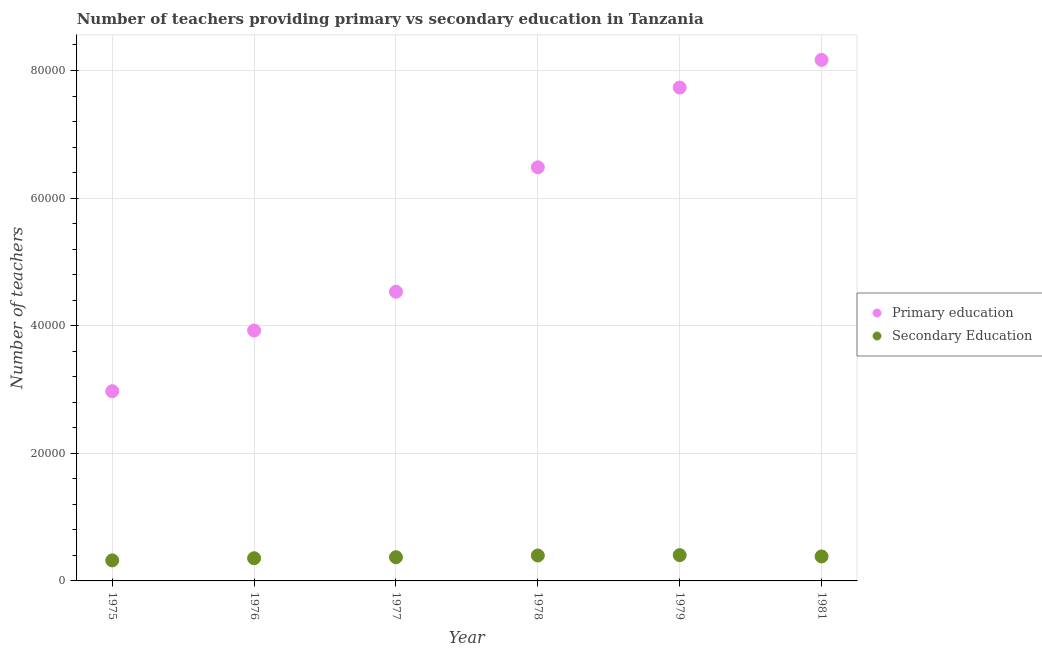How many different coloured dotlines are there?
Provide a succinct answer. 2. What is the number of secondary teachers in 1977?
Give a very brief answer. 3714. Across all years, what is the maximum number of primary teachers?
Offer a very short reply. 8.17e+04. Across all years, what is the minimum number of primary teachers?
Provide a short and direct response. 2.97e+04. In which year was the number of primary teachers minimum?
Ensure brevity in your answer.  1975. What is the total number of secondary teachers in the graph?
Provide a succinct answer. 2.23e+04. What is the difference between the number of primary teachers in 1975 and that in 1977?
Keep it short and to the point. -1.56e+04. What is the difference between the number of secondary teachers in 1975 and the number of primary teachers in 1976?
Provide a short and direct response. -3.60e+04. What is the average number of secondary teachers per year?
Your answer should be very brief. 3724.83. In the year 1975, what is the difference between the number of secondary teachers and number of primary teachers?
Your response must be concise. -2.65e+04. In how many years, is the number of secondary teachers greater than 52000?
Ensure brevity in your answer.  0. What is the ratio of the number of secondary teachers in 1977 to that in 1978?
Give a very brief answer. 0.93. Is the number of primary teachers in 1977 less than that in 1979?
Make the answer very short. Yes. What is the difference between the highest and the lowest number of primary teachers?
Your response must be concise. 5.19e+04. In how many years, is the number of primary teachers greater than the average number of primary teachers taken over all years?
Keep it short and to the point. 3. Does the number of secondary teachers monotonically increase over the years?
Offer a very short reply. No. Is the number of primary teachers strictly greater than the number of secondary teachers over the years?
Your response must be concise. Yes. How many dotlines are there?
Give a very brief answer. 2. How many years are there in the graph?
Your answer should be very brief. 6. What is the difference between two consecutive major ticks on the Y-axis?
Give a very brief answer. 2.00e+04. Are the values on the major ticks of Y-axis written in scientific E-notation?
Your answer should be compact. No. Does the graph contain grids?
Provide a succinct answer. Yes. How many legend labels are there?
Make the answer very short. 2. What is the title of the graph?
Make the answer very short. Number of teachers providing primary vs secondary education in Tanzania. Does "Secondary" appear as one of the legend labels in the graph?
Your answer should be very brief. No. What is the label or title of the X-axis?
Offer a very short reply. Year. What is the label or title of the Y-axis?
Provide a short and direct response. Number of teachers. What is the Number of teachers in Primary education in 1975?
Keep it short and to the point. 2.97e+04. What is the Number of teachers in Secondary Education in 1975?
Make the answer very short. 3218. What is the Number of teachers of Primary education in 1976?
Your answer should be compact. 3.92e+04. What is the Number of teachers in Secondary Education in 1976?
Offer a terse response. 3557. What is the Number of teachers of Primary education in 1977?
Make the answer very short. 4.53e+04. What is the Number of teachers of Secondary Education in 1977?
Your answer should be compact. 3714. What is the Number of teachers in Primary education in 1978?
Provide a short and direct response. 6.48e+04. What is the Number of teachers of Secondary Education in 1978?
Your answer should be compact. 3985. What is the Number of teachers in Primary education in 1979?
Your answer should be very brief. 7.73e+04. What is the Number of teachers of Secondary Education in 1979?
Keep it short and to the point. 4038. What is the Number of teachers of Primary education in 1981?
Provide a short and direct response. 8.17e+04. What is the Number of teachers of Secondary Education in 1981?
Offer a very short reply. 3837. Across all years, what is the maximum Number of teachers in Primary education?
Provide a succinct answer. 8.17e+04. Across all years, what is the maximum Number of teachers in Secondary Education?
Offer a terse response. 4038. Across all years, what is the minimum Number of teachers of Primary education?
Your response must be concise. 2.97e+04. Across all years, what is the minimum Number of teachers in Secondary Education?
Your response must be concise. 3218. What is the total Number of teachers in Primary education in the graph?
Offer a terse response. 3.38e+05. What is the total Number of teachers of Secondary Education in the graph?
Keep it short and to the point. 2.23e+04. What is the difference between the Number of teachers of Primary education in 1975 and that in 1976?
Your response must be concise. -9510. What is the difference between the Number of teachers of Secondary Education in 1975 and that in 1976?
Provide a short and direct response. -339. What is the difference between the Number of teachers in Primary education in 1975 and that in 1977?
Your response must be concise. -1.56e+04. What is the difference between the Number of teachers in Secondary Education in 1975 and that in 1977?
Ensure brevity in your answer.  -496. What is the difference between the Number of teachers in Primary education in 1975 and that in 1978?
Ensure brevity in your answer.  -3.51e+04. What is the difference between the Number of teachers in Secondary Education in 1975 and that in 1978?
Ensure brevity in your answer.  -767. What is the difference between the Number of teachers of Primary education in 1975 and that in 1979?
Provide a short and direct response. -4.76e+04. What is the difference between the Number of teachers of Secondary Education in 1975 and that in 1979?
Give a very brief answer. -820. What is the difference between the Number of teachers of Primary education in 1975 and that in 1981?
Keep it short and to the point. -5.19e+04. What is the difference between the Number of teachers in Secondary Education in 1975 and that in 1981?
Ensure brevity in your answer.  -619. What is the difference between the Number of teachers of Primary education in 1976 and that in 1977?
Offer a terse response. -6085. What is the difference between the Number of teachers of Secondary Education in 1976 and that in 1977?
Provide a short and direct response. -157. What is the difference between the Number of teachers of Primary education in 1976 and that in 1978?
Provide a succinct answer. -2.56e+04. What is the difference between the Number of teachers in Secondary Education in 1976 and that in 1978?
Your answer should be compact. -428. What is the difference between the Number of teachers in Primary education in 1976 and that in 1979?
Offer a very short reply. -3.81e+04. What is the difference between the Number of teachers of Secondary Education in 1976 and that in 1979?
Give a very brief answer. -481. What is the difference between the Number of teachers in Primary education in 1976 and that in 1981?
Offer a terse response. -4.24e+04. What is the difference between the Number of teachers of Secondary Education in 1976 and that in 1981?
Give a very brief answer. -280. What is the difference between the Number of teachers in Primary education in 1977 and that in 1978?
Offer a very short reply. -1.95e+04. What is the difference between the Number of teachers of Secondary Education in 1977 and that in 1978?
Provide a short and direct response. -271. What is the difference between the Number of teachers of Primary education in 1977 and that in 1979?
Make the answer very short. -3.20e+04. What is the difference between the Number of teachers of Secondary Education in 1977 and that in 1979?
Provide a short and direct response. -324. What is the difference between the Number of teachers of Primary education in 1977 and that in 1981?
Your answer should be compact. -3.63e+04. What is the difference between the Number of teachers of Secondary Education in 1977 and that in 1981?
Offer a very short reply. -123. What is the difference between the Number of teachers in Primary education in 1978 and that in 1979?
Your answer should be very brief. -1.25e+04. What is the difference between the Number of teachers in Secondary Education in 1978 and that in 1979?
Give a very brief answer. -53. What is the difference between the Number of teachers of Primary education in 1978 and that in 1981?
Offer a terse response. -1.68e+04. What is the difference between the Number of teachers in Secondary Education in 1978 and that in 1981?
Provide a succinct answer. 148. What is the difference between the Number of teachers of Primary education in 1979 and that in 1981?
Your response must be concise. -4330. What is the difference between the Number of teachers in Secondary Education in 1979 and that in 1981?
Keep it short and to the point. 201. What is the difference between the Number of teachers in Primary education in 1975 and the Number of teachers in Secondary Education in 1976?
Provide a short and direct response. 2.62e+04. What is the difference between the Number of teachers of Primary education in 1975 and the Number of teachers of Secondary Education in 1977?
Give a very brief answer. 2.60e+04. What is the difference between the Number of teachers in Primary education in 1975 and the Number of teachers in Secondary Education in 1978?
Make the answer very short. 2.58e+04. What is the difference between the Number of teachers in Primary education in 1975 and the Number of teachers in Secondary Education in 1979?
Your answer should be compact. 2.57e+04. What is the difference between the Number of teachers of Primary education in 1975 and the Number of teachers of Secondary Education in 1981?
Your answer should be very brief. 2.59e+04. What is the difference between the Number of teachers in Primary education in 1976 and the Number of teachers in Secondary Education in 1977?
Your response must be concise. 3.55e+04. What is the difference between the Number of teachers of Primary education in 1976 and the Number of teachers of Secondary Education in 1978?
Provide a succinct answer. 3.53e+04. What is the difference between the Number of teachers in Primary education in 1976 and the Number of teachers in Secondary Education in 1979?
Keep it short and to the point. 3.52e+04. What is the difference between the Number of teachers of Primary education in 1976 and the Number of teachers of Secondary Education in 1981?
Keep it short and to the point. 3.54e+04. What is the difference between the Number of teachers in Primary education in 1977 and the Number of teachers in Secondary Education in 1978?
Offer a very short reply. 4.13e+04. What is the difference between the Number of teachers of Primary education in 1977 and the Number of teachers of Secondary Education in 1979?
Your answer should be very brief. 4.13e+04. What is the difference between the Number of teachers in Primary education in 1977 and the Number of teachers in Secondary Education in 1981?
Offer a very short reply. 4.15e+04. What is the difference between the Number of teachers in Primary education in 1978 and the Number of teachers in Secondary Education in 1979?
Provide a short and direct response. 6.08e+04. What is the difference between the Number of teachers of Primary education in 1978 and the Number of teachers of Secondary Education in 1981?
Provide a succinct answer. 6.10e+04. What is the difference between the Number of teachers in Primary education in 1979 and the Number of teachers in Secondary Education in 1981?
Provide a short and direct response. 7.35e+04. What is the average Number of teachers in Primary education per year?
Provide a succinct answer. 5.64e+04. What is the average Number of teachers in Secondary Education per year?
Offer a very short reply. 3724.83. In the year 1975, what is the difference between the Number of teachers of Primary education and Number of teachers of Secondary Education?
Offer a very short reply. 2.65e+04. In the year 1976, what is the difference between the Number of teachers in Primary education and Number of teachers in Secondary Education?
Your response must be concise. 3.57e+04. In the year 1977, what is the difference between the Number of teachers in Primary education and Number of teachers in Secondary Education?
Provide a short and direct response. 4.16e+04. In the year 1978, what is the difference between the Number of teachers in Primary education and Number of teachers in Secondary Education?
Your answer should be very brief. 6.08e+04. In the year 1979, what is the difference between the Number of teachers in Primary education and Number of teachers in Secondary Education?
Your response must be concise. 7.33e+04. In the year 1981, what is the difference between the Number of teachers of Primary education and Number of teachers of Secondary Education?
Give a very brief answer. 7.78e+04. What is the ratio of the Number of teachers of Primary education in 1975 to that in 1976?
Your answer should be compact. 0.76. What is the ratio of the Number of teachers in Secondary Education in 1975 to that in 1976?
Your response must be concise. 0.9. What is the ratio of the Number of teachers of Primary education in 1975 to that in 1977?
Your answer should be very brief. 0.66. What is the ratio of the Number of teachers of Secondary Education in 1975 to that in 1977?
Your answer should be compact. 0.87. What is the ratio of the Number of teachers of Primary education in 1975 to that in 1978?
Offer a very short reply. 0.46. What is the ratio of the Number of teachers of Secondary Education in 1975 to that in 1978?
Provide a short and direct response. 0.81. What is the ratio of the Number of teachers of Primary education in 1975 to that in 1979?
Offer a very short reply. 0.38. What is the ratio of the Number of teachers of Secondary Education in 1975 to that in 1979?
Ensure brevity in your answer.  0.8. What is the ratio of the Number of teachers of Primary education in 1975 to that in 1981?
Ensure brevity in your answer.  0.36. What is the ratio of the Number of teachers in Secondary Education in 1975 to that in 1981?
Provide a short and direct response. 0.84. What is the ratio of the Number of teachers of Primary education in 1976 to that in 1977?
Offer a terse response. 0.87. What is the ratio of the Number of teachers in Secondary Education in 1976 to that in 1977?
Your answer should be compact. 0.96. What is the ratio of the Number of teachers in Primary education in 1976 to that in 1978?
Your answer should be very brief. 0.61. What is the ratio of the Number of teachers of Secondary Education in 1976 to that in 1978?
Provide a short and direct response. 0.89. What is the ratio of the Number of teachers of Primary education in 1976 to that in 1979?
Your answer should be very brief. 0.51. What is the ratio of the Number of teachers of Secondary Education in 1976 to that in 1979?
Offer a terse response. 0.88. What is the ratio of the Number of teachers in Primary education in 1976 to that in 1981?
Offer a very short reply. 0.48. What is the ratio of the Number of teachers of Secondary Education in 1976 to that in 1981?
Offer a terse response. 0.93. What is the ratio of the Number of teachers in Primary education in 1977 to that in 1978?
Keep it short and to the point. 0.7. What is the ratio of the Number of teachers of Secondary Education in 1977 to that in 1978?
Provide a succinct answer. 0.93. What is the ratio of the Number of teachers in Primary education in 1977 to that in 1979?
Provide a succinct answer. 0.59. What is the ratio of the Number of teachers in Secondary Education in 1977 to that in 1979?
Offer a terse response. 0.92. What is the ratio of the Number of teachers of Primary education in 1977 to that in 1981?
Give a very brief answer. 0.56. What is the ratio of the Number of teachers in Secondary Education in 1977 to that in 1981?
Your answer should be very brief. 0.97. What is the ratio of the Number of teachers of Primary education in 1978 to that in 1979?
Make the answer very short. 0.84. What is the ratio of the Number of teachers of Secondary Education in 1978 to that in 1979?
Offer a terse response. 0.99. What is the ratio of the Number of teachers in Primary education in 1978 to that in 1981?
Your answer should be very brief. 0.79. What is the ratio of the Number of teachers in Secondary Education in 1978 to that in 1981?
Your answer should be very brief. 1.04. What is the ratio of the Number of teachers of Primary education in 1979 to that in 1981?
Give a very brief answer. 0.95. What is the ratio of the Number of teachers of Secondary Education in 1979 to that in 1981?
Offer a terse response. 1.05. What is the difference between the highest and the second highest Number of teachers of Primary education?
Give a very brief answer. 4330. What is the difference between the highest and the lowest Number of teachers of Primary education?
Keep it short and to the point. 5.19e+04. What is the difference between the highest and the lowest Number of teachers of Secondary Education?
Offer a terse response. 820. 